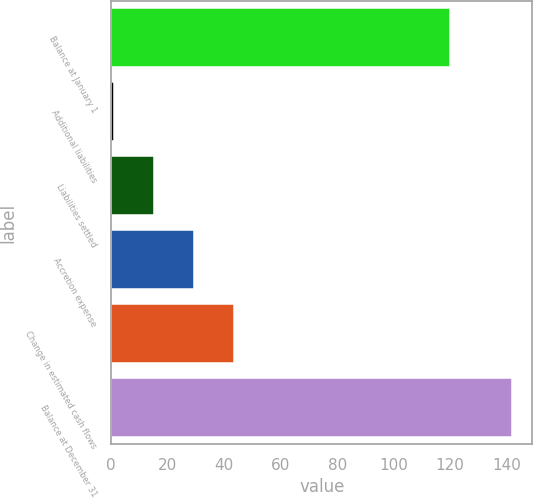Convert chart to OTSL. <chart><loc_0><loc_0><loc_500><loc_500><bar_chart><fcel>Balance at January 1<fcel>Additional liabilities<fcel>Liabilities settled<fcel>Accretion expense<fcel>Change in estimated cash flows<fcel>Balance at December 31<nl><fcel>120<fcel>1<fcel>15.1<fcel>29.2<fcel>43.3<fcel>142<nl></chart> 